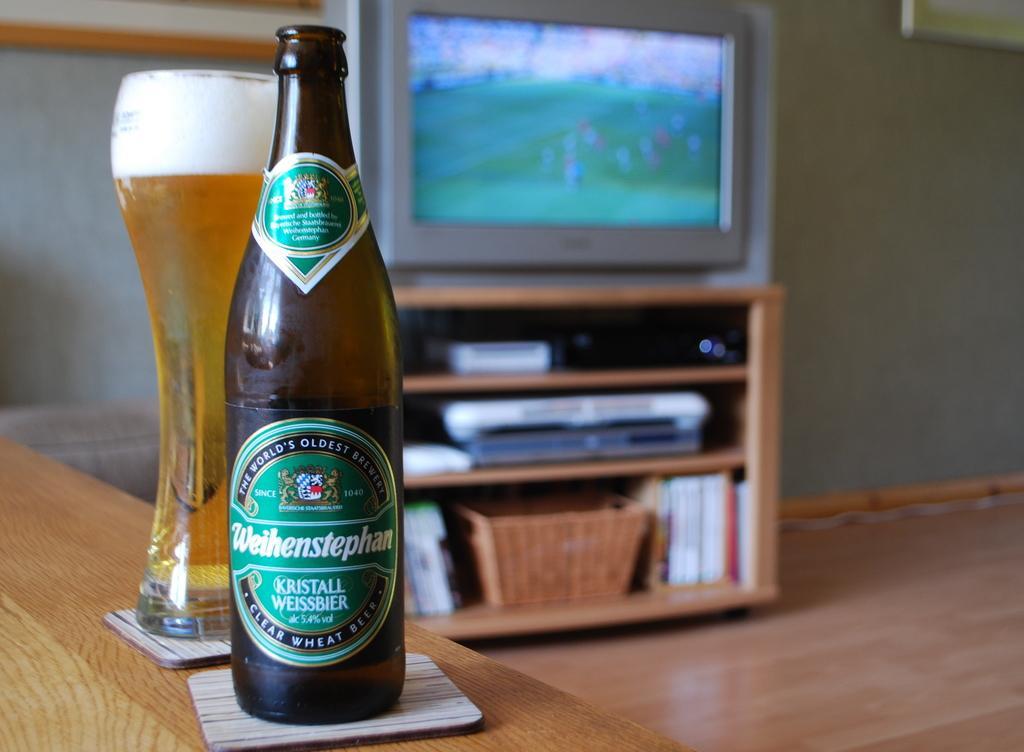Describe this image in one or two sentences. In this image there is a bottle of beer and a glass of beer are placed on the wooden table, in the background of the image there is a television on the television stand, inside the television stand on the shelf there is a DVD player and some books placed. 